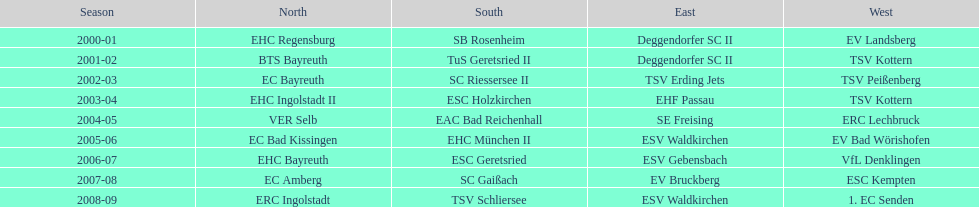Write the full table. {'header': ['Season', 'North', 'South', 'East', 'West'], 'rows': [['2000-01', 'EHC Regensburg', 'SB Rosenheim', 'Deggendorfer SC II', 'EV Landsberg'], ['2001-02', 'BTS Bayreuth', 'TuS Geretsried II', 'Deggendorfer SC II', 'TSV Kottern'], ['2002-03', 'EC Bayreuth', 'SC Riessersee II', 'TSV Erding Jets', 'TSV Peißenberg'], ['2003-04', 'EHC Ingolstadt II', 'ESC Holzkirchen', 'EHF Passau', 'TSV Kottern'], ['2004-05', 'VER Selb', 'EAC Bad Reichenhall', 'SE Freising', 'ERC Lechbruck'], ['2005-06', 'EC Bad Kissingen', 'EHC München II', 'ESV Waldkirchen', 'EV Bad Wörishofen'], ['2006-07', 'EHC Bayreuth', 'ESC Geretsried', 'ESV Gebensbach', 'VfL Denklingen'], ['2007-08', 'EC Amberg', 'SC Gaißach', 'EV Bruckberg', 'ESC Kempten'], ['2008-09', 'ERC Ingolstadt', 'TSV Schliersee', 'ESV Waldkirchen', '1. EC Senden']]} Between kottern and bayreuth, which name occurs more often? Bayreuth. 